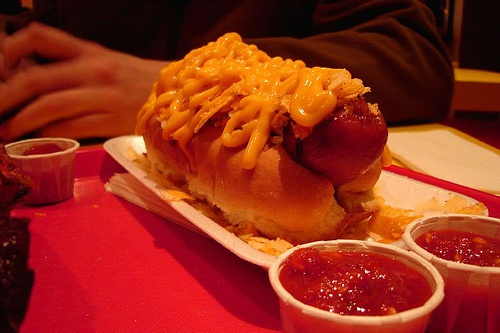Describe the objects in this image and their specific colors. I can see dining table in black, brown, red, and maroon tones, people in black, maroon, and brown tones, hot dog in black, brown, red, maroon, and orange tones, bowl in black, brown, and tan tones, and bowl in black, brown, maroon, and tan tones in this image. 